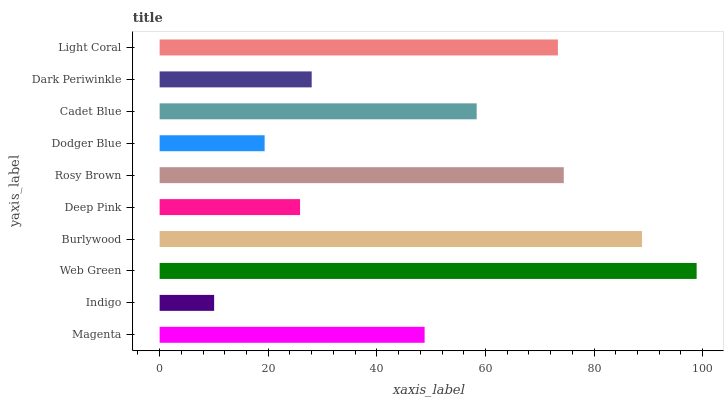Is Indigo the minimum?
Answer yes or no. Yes. Is Web Green the maximum?
Answer yes or no. Yes. Is Web Green the minimum?
Answer yes or no. No. Is Indigo the maximum?
Answer yes or no. No. Is Web Green greater than Indigo?
Answer yes or no. Yes. Is Indigo less than Web Green?
Answer yes or no. Yes. Is Indigo greater than Web Green?
Answer yes or no. No. Is Web Green less than Indigo?
Answer yes or no. No. Is Cadet Blue the high median?
Answer yes or no. Yes. Is Magenta the low median?
Answer yes or no. Yes. Is Rosy Brown the high median?
Answer yes or no. No. Is Light Coral the low median?
Answer yes or no. No. 